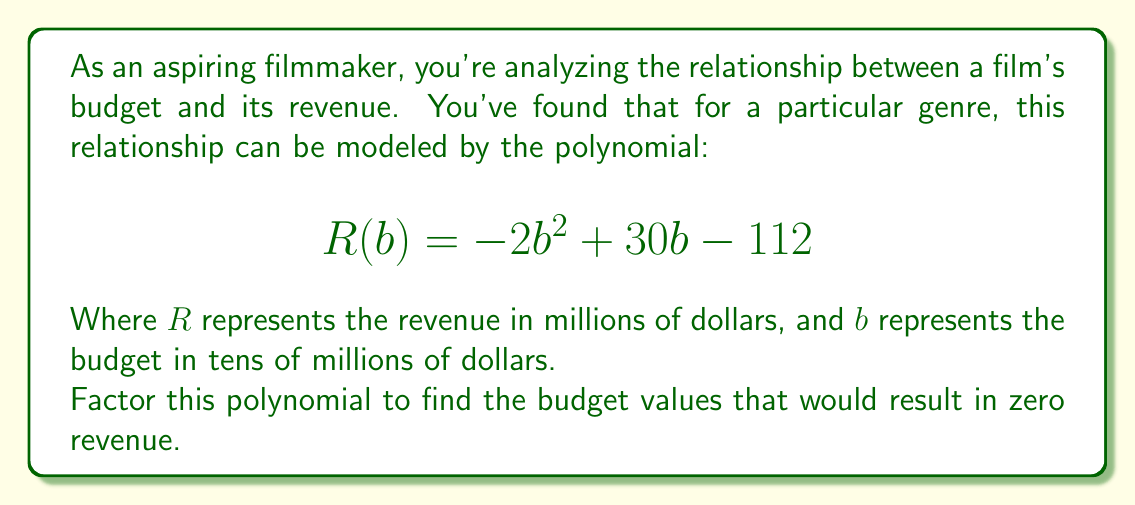Show me your answer to this math problem. Let's approach this step-by-step:

1) The polynomial is in the form $ax^2 + bx + c$, where:
   $a = -2$, $b = 30$, and $c = -112$

2) To factor this quadratic equation, we'll use the quadratic formula:
   $$x = \frac{-b \pm \sqrt{b^2 - 4ac}}{2a}$$

3) Let's substitute our values:
   $$b = \frac{-30 \pm \sqrt{30^2 - 4(-2)(-112)}}{2(-2)}$$

4) Simplify under the square root:
   $$b = \frac{-30 \pm \sqrt{900 - 896}}{-4} = \frac{-30 \pm \sqrt{4}}{-4}$$

5) Simplify further:
   $$b = \frac{-30 \pm 2}{-4}$$

6) This gives us two solutions:
   $$b = \frac{-30 + 2}{-4} = 7 \quad \text{and} \quad b = \frac{-30 - 2}{-4} = 8$$

7) Therefore, our factored polynomial is:
   $$R(b) = -2(b - 7)(b - 8)$$

This means the budget values that would result in zero revenue are 7 and 8 tens of millions of dollars, or $70 million and $80 million.
Answer: $$R(b) = -2(b - 7)(b - 8)$$ 